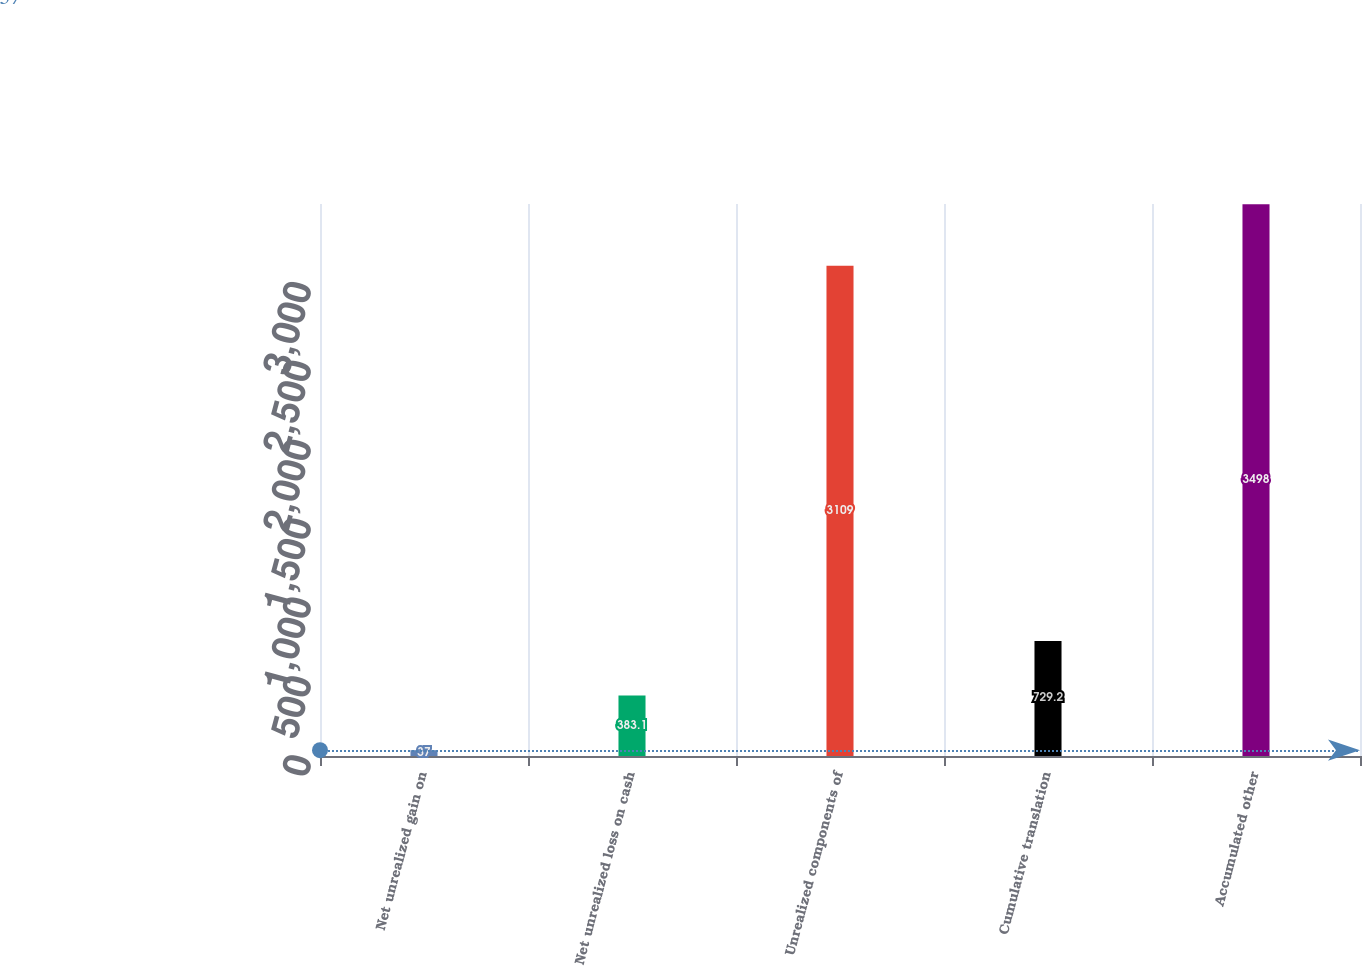Convert chart to OTSL. <chart><loc_0><loc_0><loc_500><loc_500><bar_chart><fcel>Net unrealized gain on<fcel>Net unrealized loss on cash<fcel>Unrealized components of<fcel>Cumulative translation<fcel>Accumulated other<nl><fcel>37<fcel>383.1<fcel>3109<fcel>729.2<fcel>3498<nl></chart> 